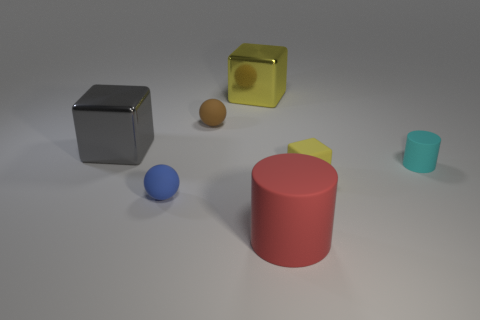Is there another big object of the same color as the big matte object?
Your answer should be very brief. No. There is a gray object; does it have the same size as the yellow block that is to the left of the small yellow rubber object?
Give a very brief answer. Yes. What number of cylinders are in front of the ball that is behind the cylinder behind the large red rubber cylinder?
Ensure brevity in your answer.  2. What is the size of the object that is the same color as the small block?
Offer a terse response. Large. There is a yellow metallic cube; are there any tiny cyan matte things behind it?
Your answer should be compact. No. What is the shape of the small cyan object?
Your response must be concise. Cylinder. There is a small thing behind the cyan cylinder that is right of the metal cube left of the big yellow object; what shape is it?
Your answer should be compact. Sphere. What number of other objects are there of the same shape as the tiny yellow rubber thing?
Your response must be concise. 2. There is a tiny sphere in front of the yellow object that is to the right of the red rubber cylinder; what is its material?
Your response must be concise. Rubber. Is there anything else that has the same size as the gray cube?
Your response must be concise. Yes. 